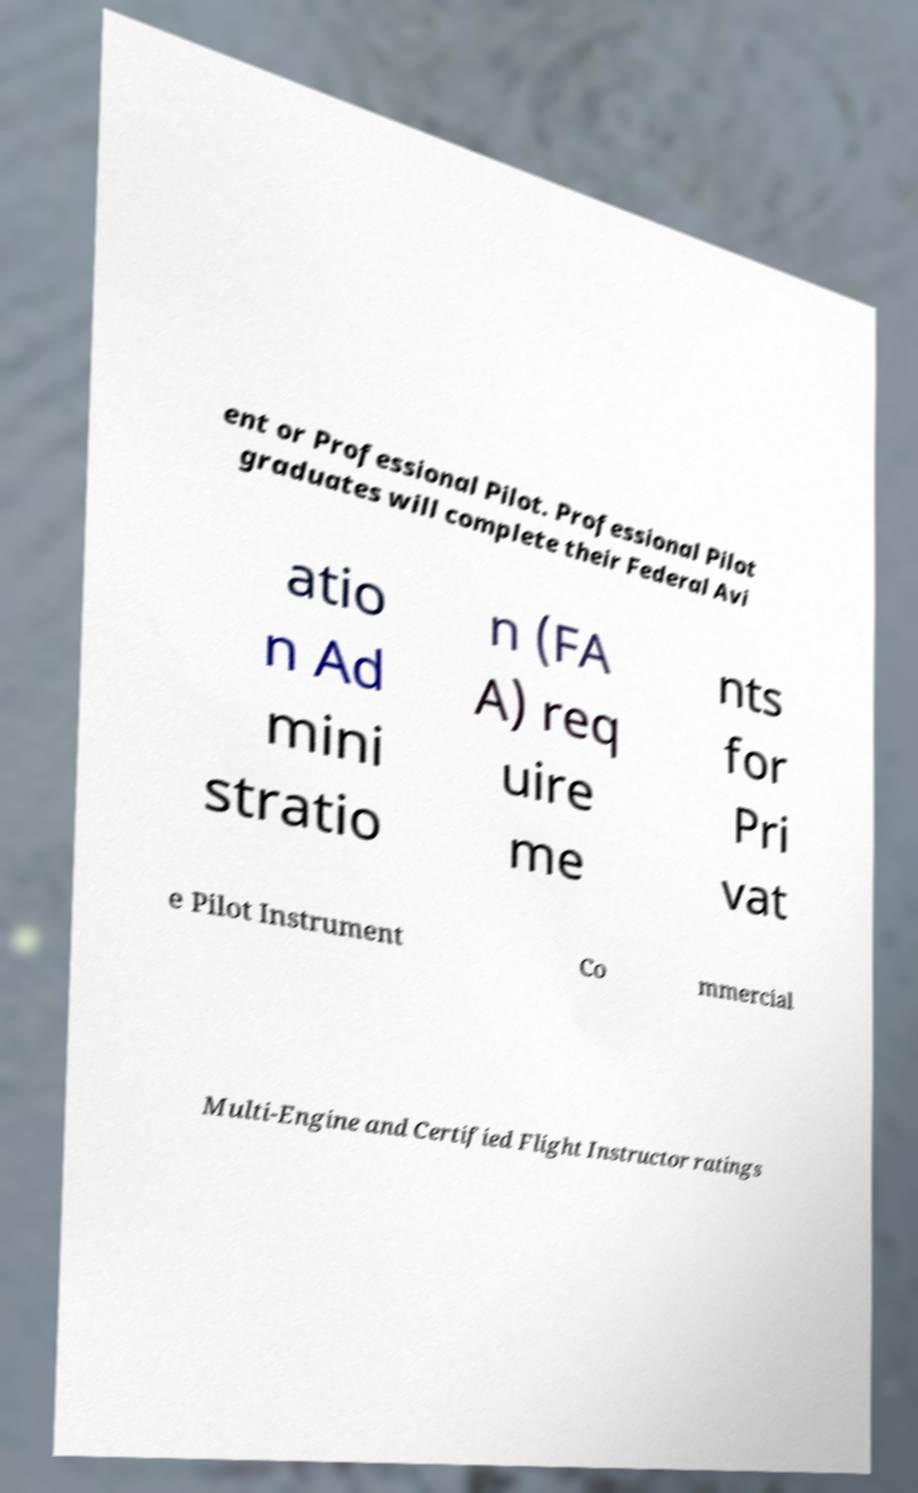Could you extract and type out the text from this image? ent or Professional Pilot. Professional Pilot graduates will complete their Federal Avi atio n Ad mini stratio n (FA A) req uire me nts for Pri vat e Pilot Instrument Co mmercial Multi-Engine and Certified Flight Instructor ratings 